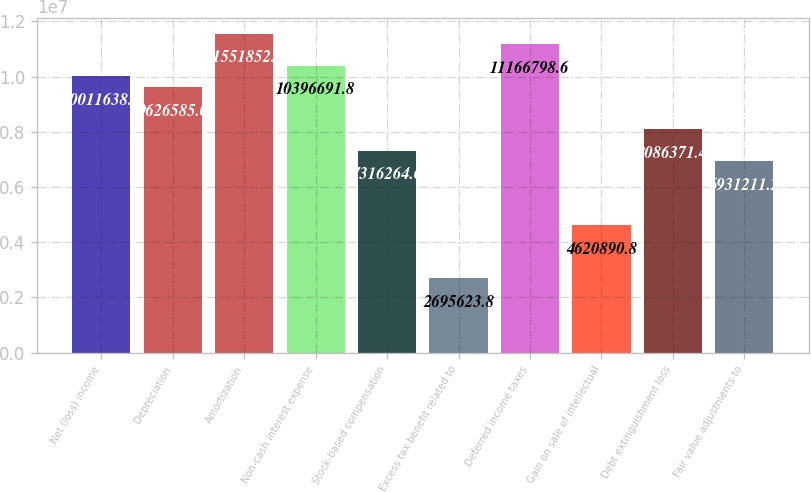Convert chart to OTSL. <chart><loc_0><loc_0><loc_500><loc_500><bar_chart><fcel>Net (loss) income<fcel>Depreciation<fcel>Amortization<fcel>Non-cash interest expense<fcel>Stock-based compensation<fcel>Excess tax benefit related to<fcel>Deferred income taxes<fcel>Gain on sale of intellectual<fcel>Debt extinguishment loss<fcel>Fair value adjustments to<nl><fcel>1.00116e+07<fcel>9.62658e+06<fcel>1.15519e+07<fcel>1.03967e+07<fcel>7.31626e+06<fcel>2.69562e+06<fcel>1.11668e+07<fcel>4.62089e+06<fcel>8.08637e+06<fcel>6.93121e+06<nl></chart> 